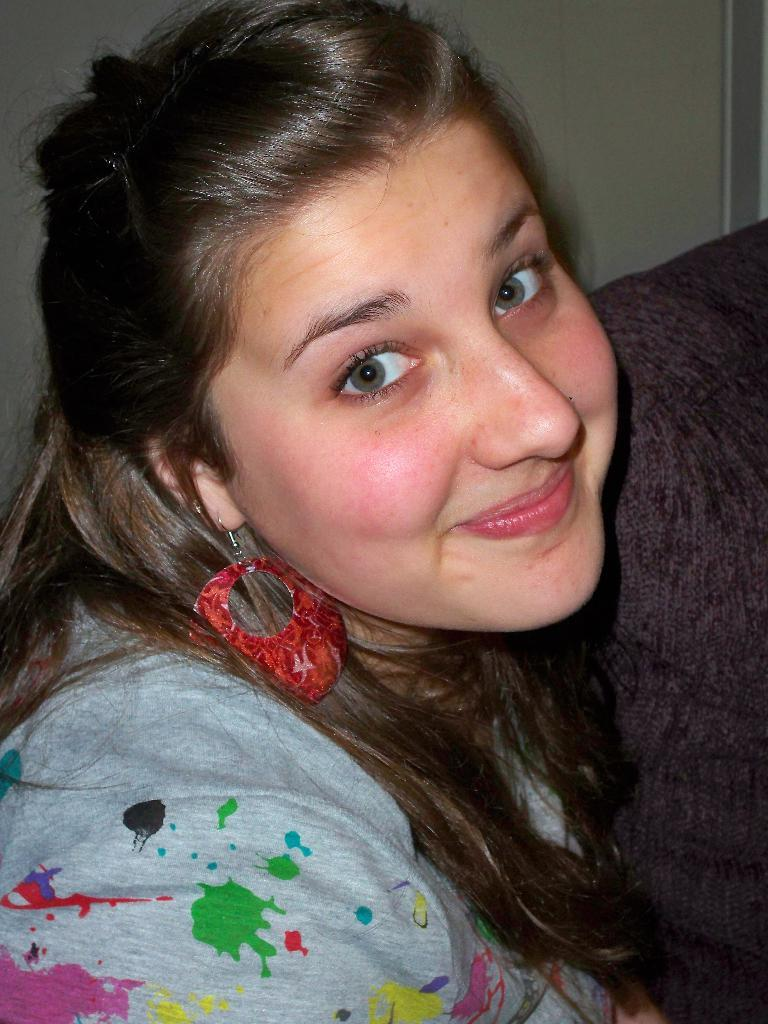Who is present in the image? There is a woman in the image. What is the woman's facial expression? The woman is smiling. What can be seen in the background of the image? There is a wall and an object in the background of the image. What type of trousers is the woman wearing in the image? The provided facts do not mention the woman's clothing, so it cannot be determined if she is wearing trousers or any other type of clothing. --- Facts: 1. There is a car in the image. 2. The car is red. 3. The car has four wheels. 4. There is a road in the image. 5. The road is paved. Absurd Topics: parrot, sand, mountain Conversation: What is the main subject of the image? The main subject of the image is a car. What color is the car? The car is red. How many wheels does the car have? The car has four wheels. What can be seen in the background of the image? There is a road in the image. What is the surface of the road? The road is paved. Reasoning: Let's think step by step in order to produce the conversation. We start by identifying the main subject in the image, which is the car. Then, we describe the car's color and the number of wheels it has. Next, we expand the conversation to include the background of the image, mentioning the road and its paved surface. Each question is designed to elicit a specific detail about the image that is known from the provided facts. Absurd Question/Answer: Can you see a parrot perched on the car's roof in the image? No, there is no parrot present in the image. 